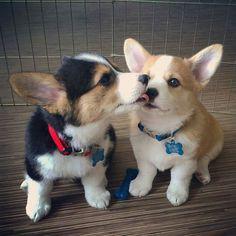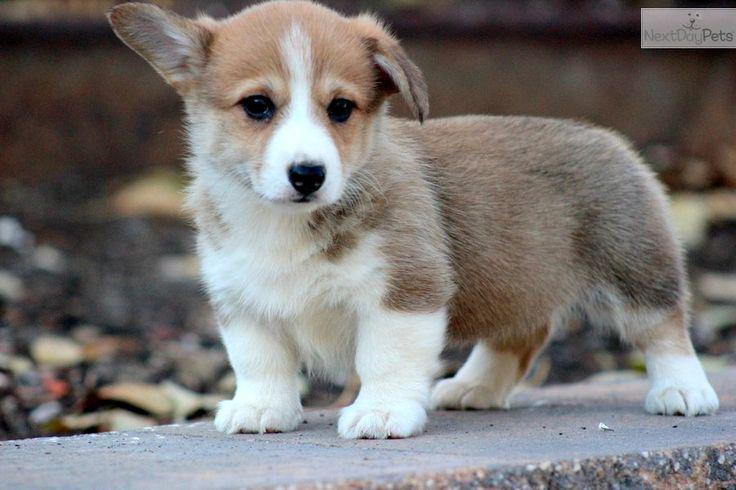The first image is the image on the left, the second image is the image on the right. Considering the images on both sides, is "Each image shows only one dog, with the dog in the right image orange-and-white, and the dog on the left tri-colored." valid? Answer yes or no. No. The first image is the image on the left, the second image is the image on the right. For the images shown, is this caption "An image contains two dogs." true? Answer yes or no. Yes. 